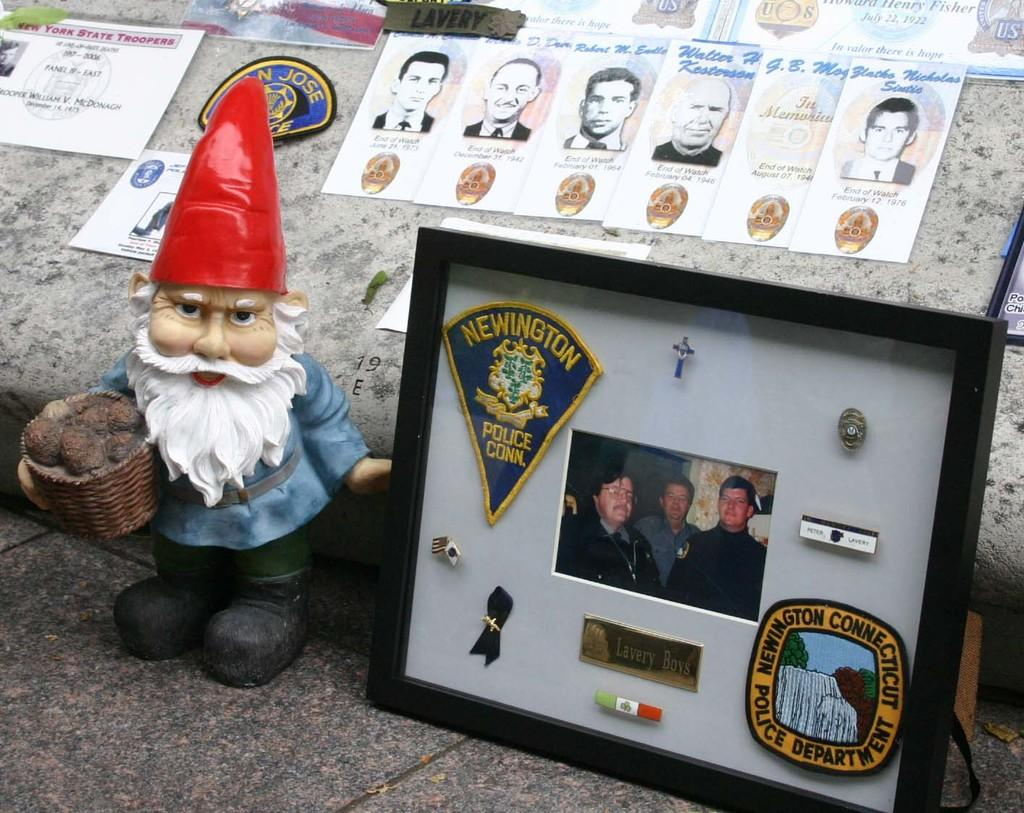What type of toy is present in the image? There is a toy Santa Claus in the image. What other items can be seen in the image? There are badges and a photo in a photo frame in the image. What is visible in the background of the image? Papers and another photo are visible in the background of the image. How are the badges positioned in the image? The badges are stick to the wall in the background of the image. Can you tell me how many lamps are in the image? There are no lamps present in the image. How does the beggar interact with the photo in the background of the image? There is no beggar present in the image, so it is not possible to answer that question. 